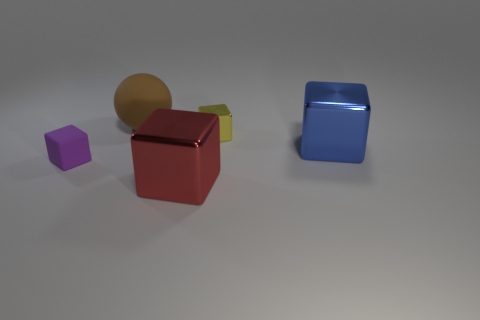Subtract all gray blocks. Subtract all cyan balls. How many blocks are left? 4 Add 5 spheres. How many objects exist? 10 Subtract all cubes. How many objects are left? 1 Subtract 0 red spheres. How many objects are left? 5 Subtract all large red metallic cubes. Subtract all large things. How many objects are left? 1 Add 2 big blue metal blocks. How many big blue metal blocks are left? 3 Add 4 yellow matte spheres. How many yellow matte spheres exist? 4 